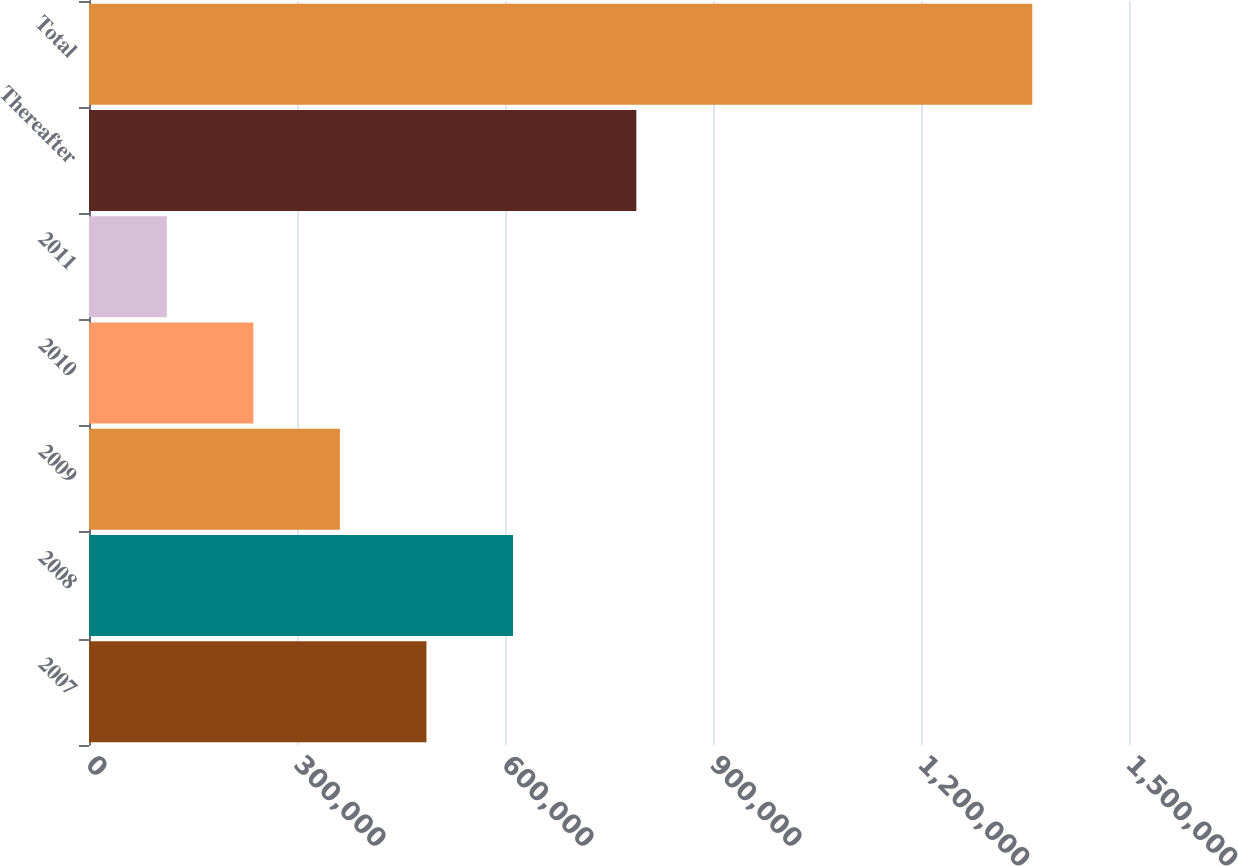Convert chart. <chart><loc_0><loc_0><loc_500><loc_500><bar_chart><fcel>2007<fcel>2008<fcel>2009<fcel>2010<fcel>2011<fcel>Thereafter<fcel>Total<nl><fcel>486708<fcel>611532<fcel>361885<fcel>237062<fcel>112238<fcel>789440<fcel>1.36047e+06<nl></chart> 